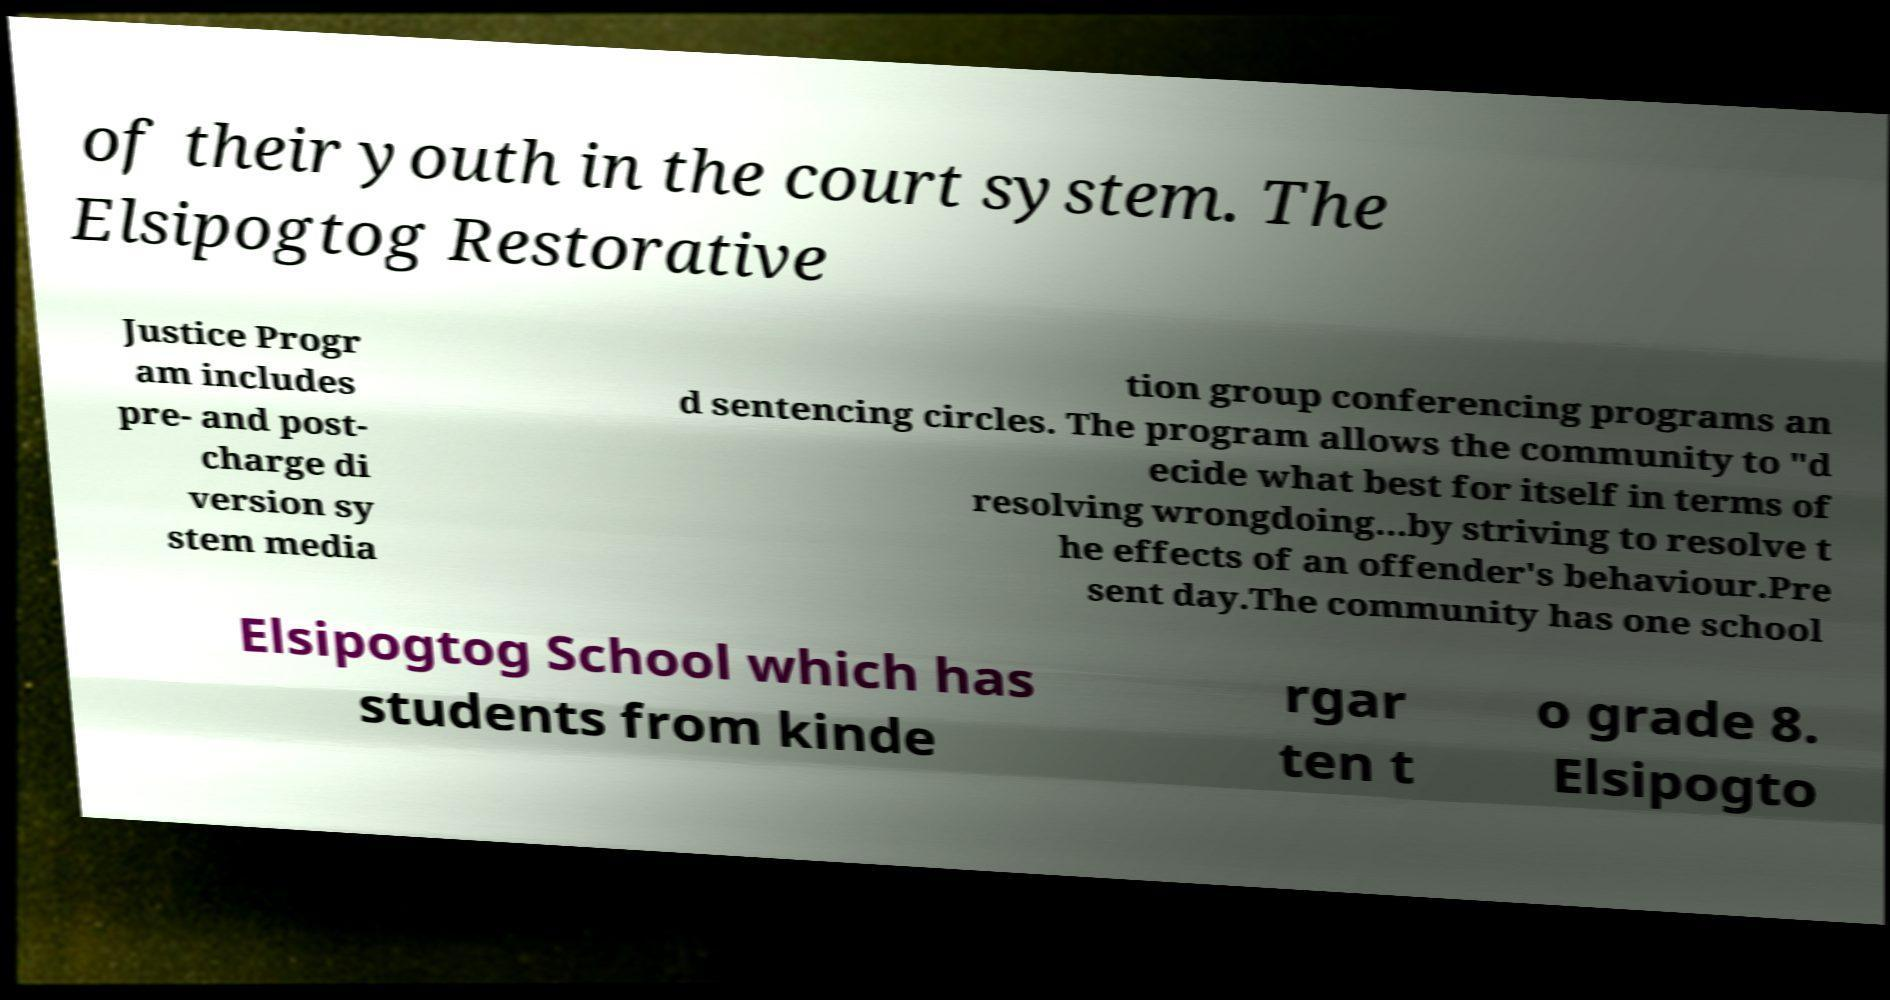Please read and relay the text visible in this image. What does it say? of their youth in the court system. The Elsipogtog Restorative Justice Progr am includes pre- and post- charge di version sy stem media tion group conferencing programs an d sentencing circles. The program allows the community to "d ecide what best for itself in terms of resolving wrongdoing...by striving to resolve t he effects of an offender's behaviour.Pre sent day.The community has one school Elsipogtog School which has students from kinde rgar ten t o grade 8. Elsipogto 